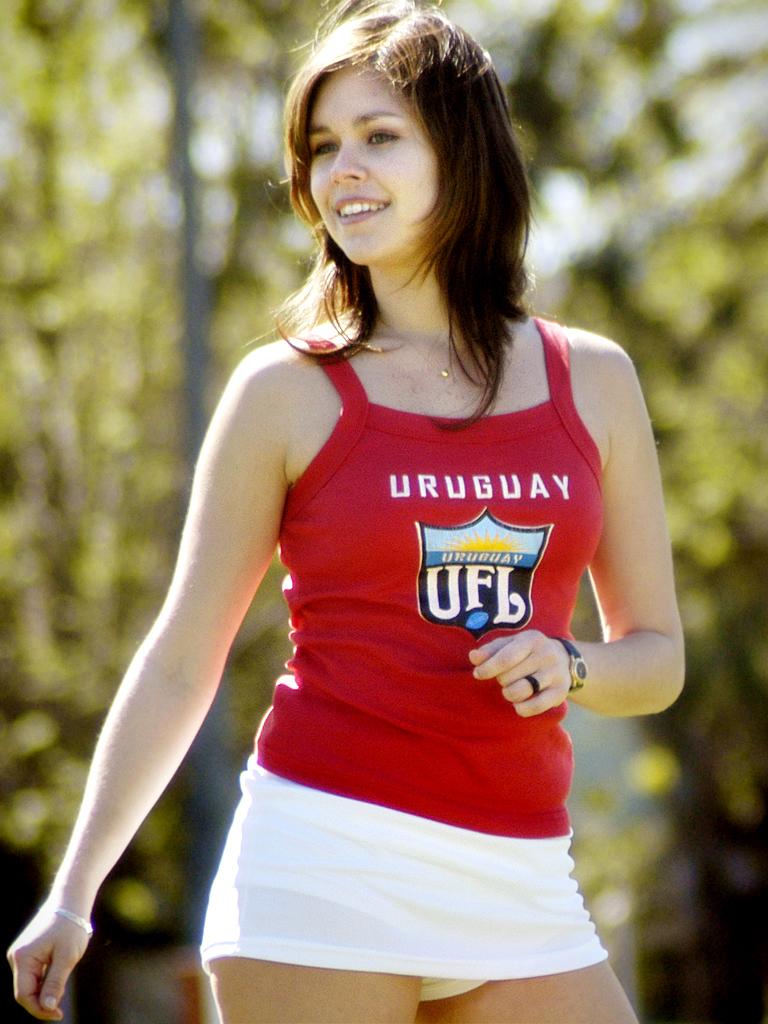What country is on the shirt?
Give a very brief answer. Uruguay. What is the abbreviation on the woman's shirt?
Ensure brevity in your answer.  Ufl. 